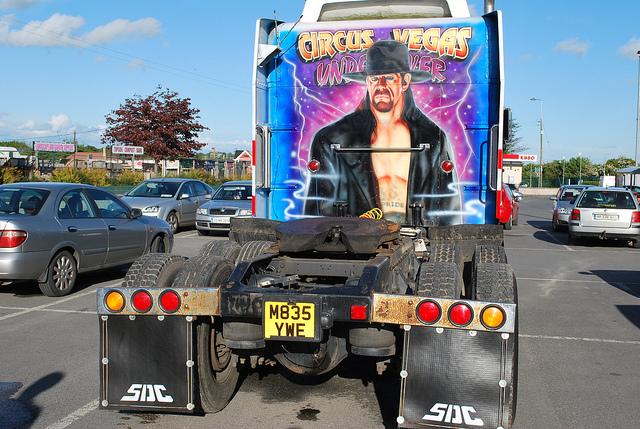To the lower left of the picture, what kind of shadow is this?
Keep it brief. Person. What color is the man's hat?
Be succinct. Black. What does the mural say?
Keep it brief. Circus vegas. 